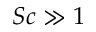Convert formula to latex. <formula><loc_0><loc_0><loc_500><loc_500>S c \gg 1</formula> 